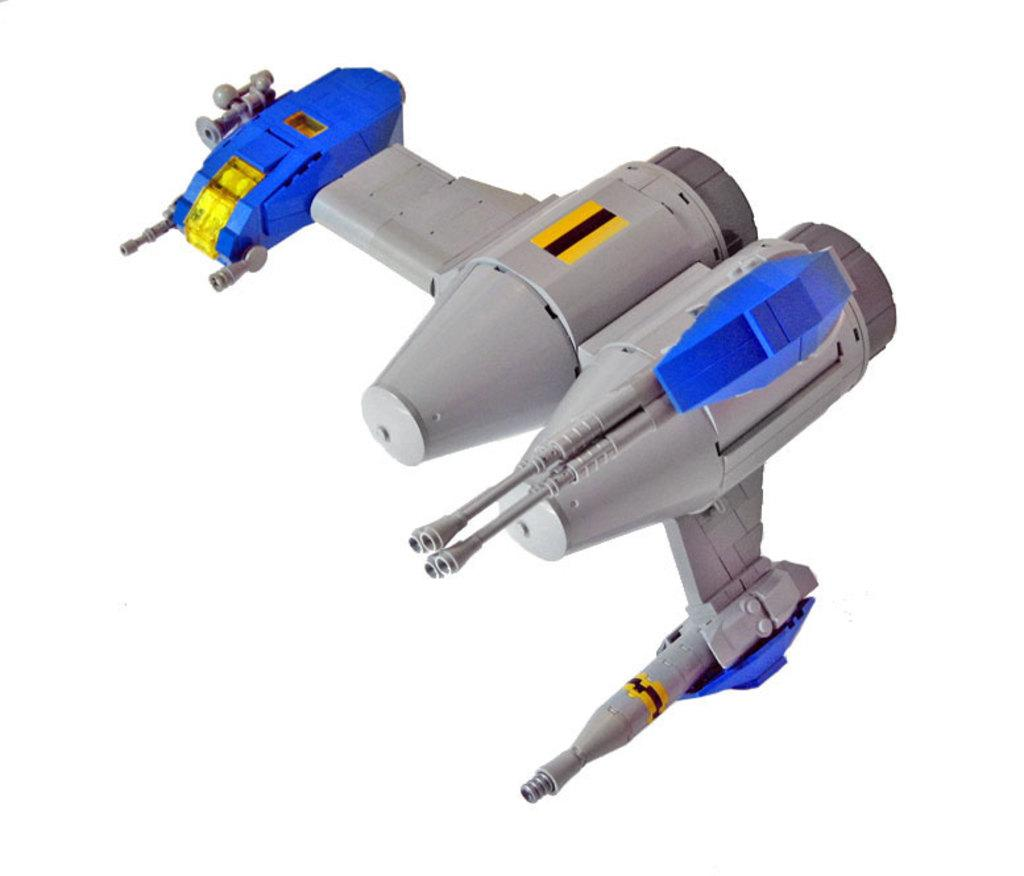What is the main subject in the image? There is an object in the image. Can you describe the colors of the object? The object has blue, grey, black, and yellow colors. Is there a hat being worn by someone in the image? There is no hat or person present in the image; it only features an object with various colors. 